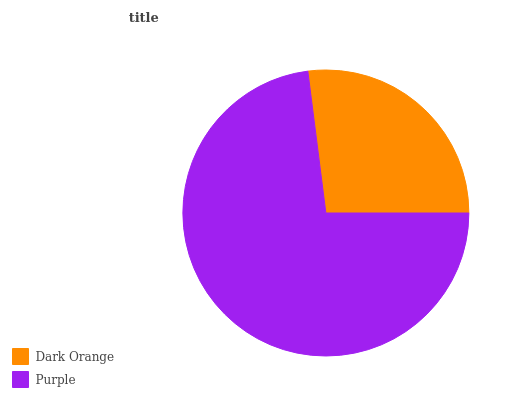Is Dark Orange the minimum?
Answer yes or no. Yes. Is Purple the maximum?
Answer yes or no. Yes. Is Purple the minimum?
Answer yes or no. No. Is Purple greater than Dark Orange?
Answer yes or no. Yes. Is Dark Orange less than Purple?
Answer yes or no. Yes. Is Dark Orange greater than Purple?
Answer yes or no. No. Is Purple less than Dark Orange?
Answer yes or no. No. Is Purple the high median?
Answer yes or no. Yes. Is Dark Orange the low median?
Answer yes or no. Yes. Is Dark Orange the high median?
Answer yes or no. No. Is Purple the low median?
Answer yes or no. No. 